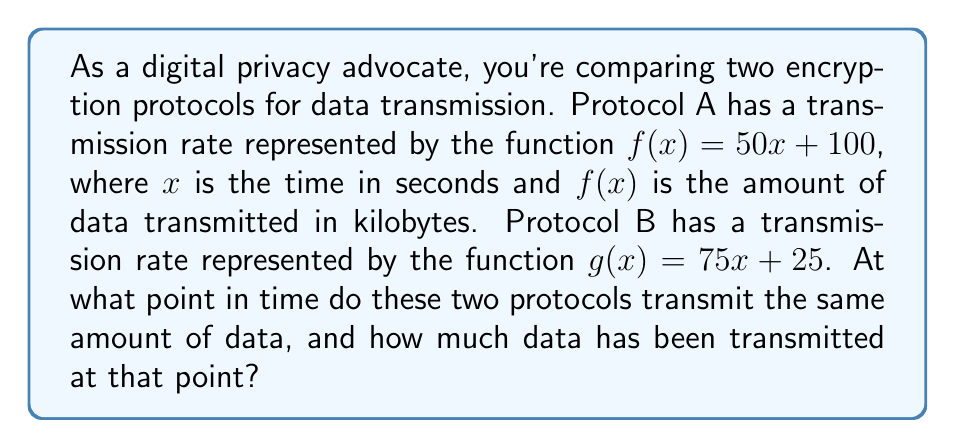Could you help me with this problem? To find the intersection point of these two linear functions, we need to solve the equation:

$$f(x) = g(x)$$

Substituting the given functions:

$$50x + 100 = 75x + 25$$

Now, let's solve this equation step by step:

1) Subtract 50x from both sides:
   $$100 = 25x + 25$$

2) Subtract 25 from both sides:
   $$75 = 25x$$

3) Divide both sides by 25:
   $$3 = x$$

So, the two protocols transmit the same amount of data after 3 seconds.

To find how much data has been transmitted at this point, we can use either function. Let's use $f(x)$:

$$f(3) = 50(3) + 100 = 150 + 100 = 250$$

Therefore, after 3 seconds, both protocols have transmitted 250 kilobytes of data.
Answer: The two protocols transmit the same amount of data after 3 seconds, at which point 250 kilobytes have been transmitted. 